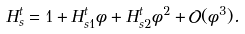Convert formula to latex. <formula><loc_0><loc_0><loc_500><loc_500>H ^ { t } _ { s } = 1 + H ^ { t } _ { s 1 } \phi + H ^ { t } _ { s 2 } \phi ^ { 2 } + \mathcal { O } ( \phi ^ { 3 } ) .</formula> 